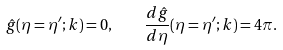<formula> <loc_0><loc_0><loc_500><loc_500>\hat { g } ( \eta = \eta ^ { \prime } ; k ) = 0 , \quad \frac { d \hat { g } } { d \eta } ( \eta = \eta ^ { \prime } ; k ) = 4 \pi .</formula> 